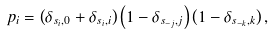<formula> <loc_0><loc_0><loc_500><loc_500>p _ { i } = \left ( \delta _ { s _ { i } , 0 } + \delta _ { s _ { i } , i } \right ) \left ( 1 - \delta _ { s _ { - j } , j } \right ) \left ( 1 - \delta _ { s _ { - k } , k } \right ) ,</formula> 